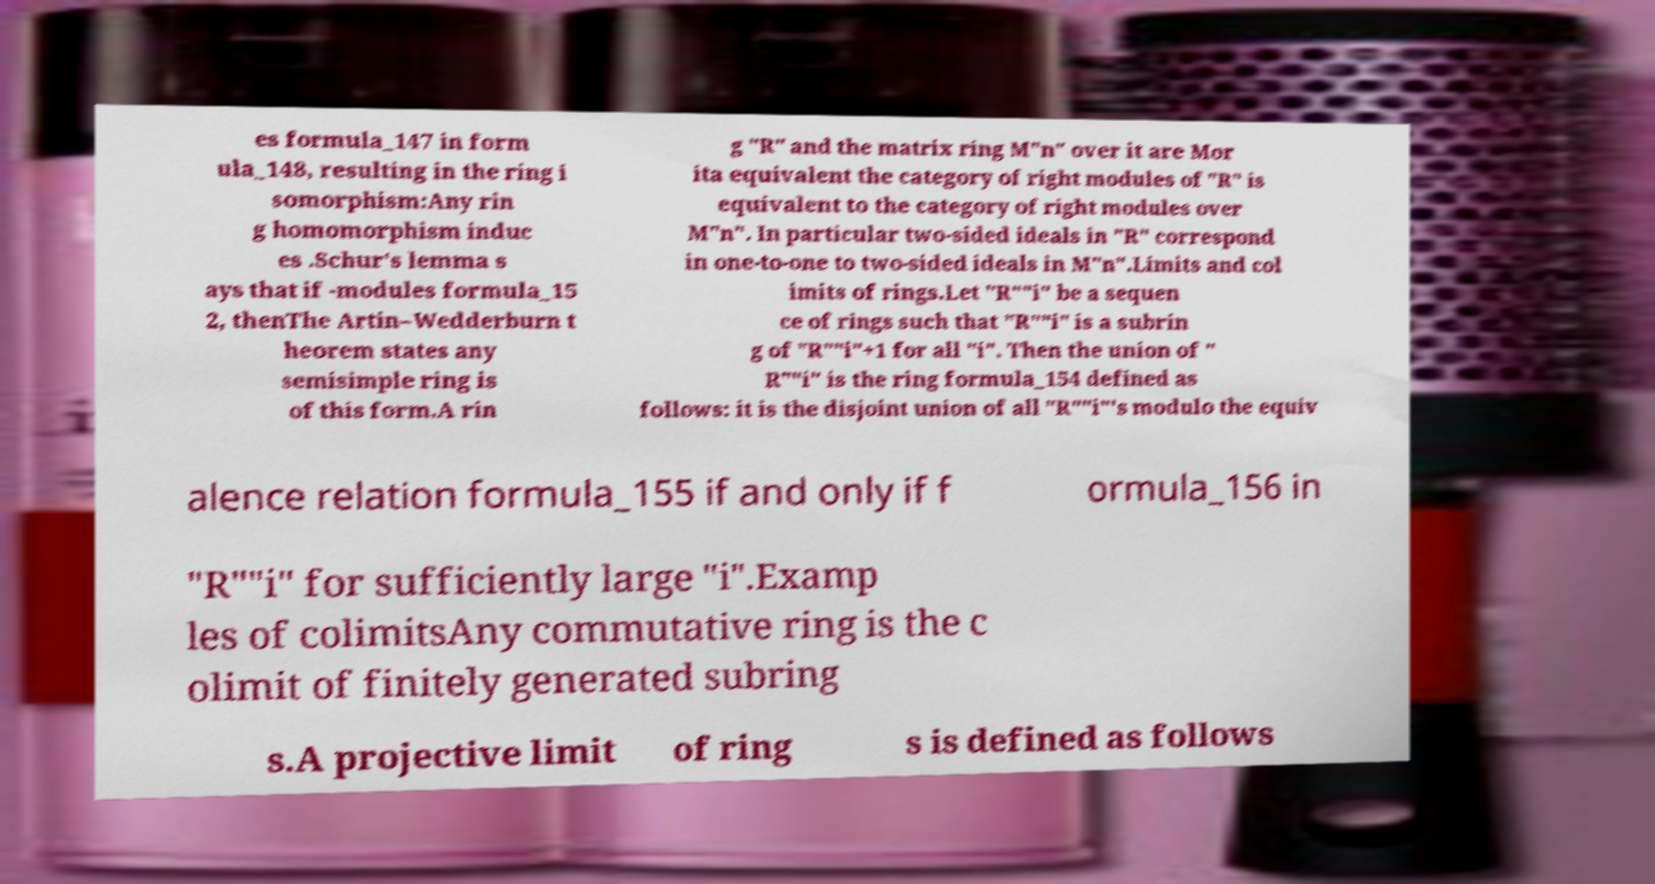What messages or text are displayed in this image? I need them in a readable, typed format. es formula_147 in form ula_148, resulting in the ring i somorphism:Any rin g homomorphism induc es .Schur's lemma s ays that if -modules formula_15 2, thenThe Artin–Wedderburn t heorem states any semisimple ring is of this form.A rin g "R" and the matrix ring M"n" over it are Mor ita equivalent the category of right modules of "R" is equivalent to the category of right modules over M"n". In particular two-sided ideals in "R" correspond in one-to-one to two-sided ideals in M"n".Limits and col imits of rings.Let "R""i" be a sequen ce of rings such that "R""i" is a subrin g of "R""i"+1 for all "i". Then the union of " R""i" is the ring formula_154 defined as follows: it is the disjoint union of all "R""i"'s modulo the equiv alence relation formula_155 if and only if f ormula_156 in "R""i" for sufficiently large "i".Examp les of colimitsAny commutative ring is the c olimit of finitely generated subring s.A projective limit of ring s is defined as follows 